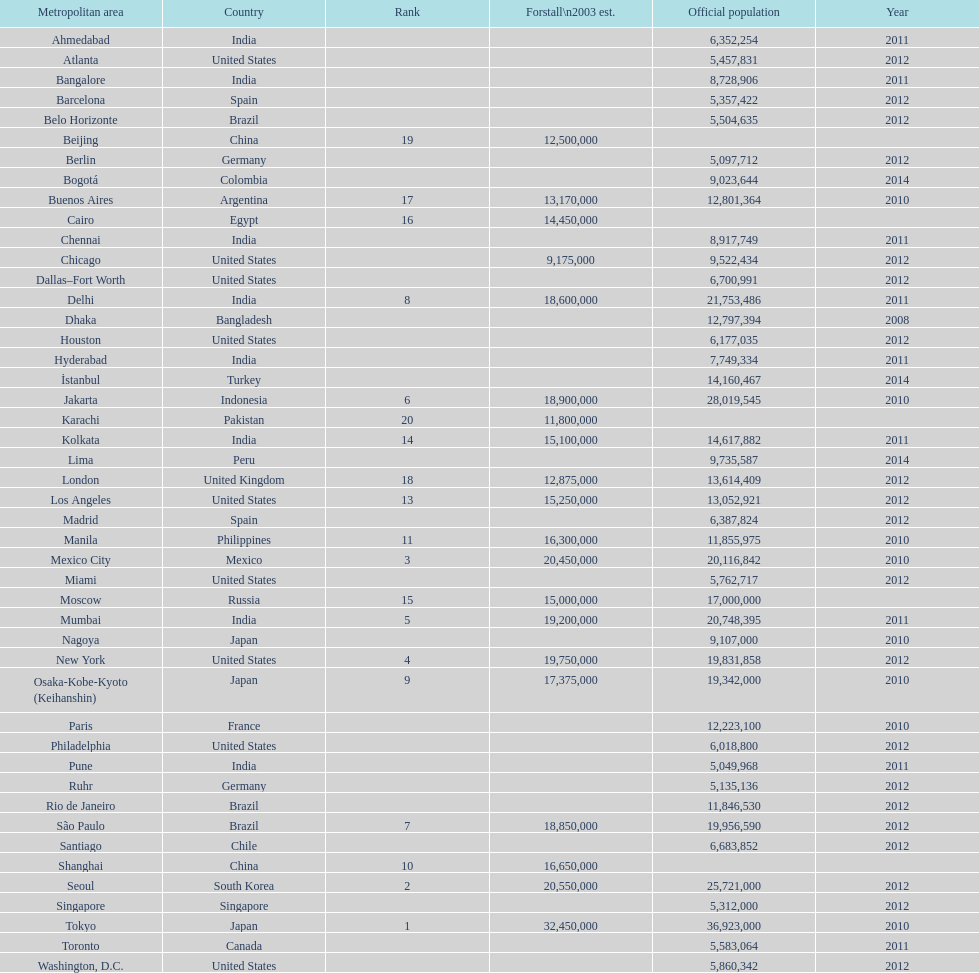State a city within the same country as bangalore. Ahmedabad. 